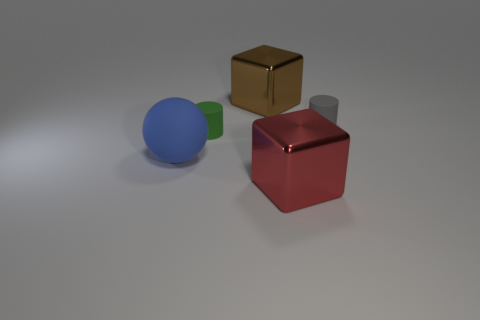How many cylinders are gray things or red metal things?
Offer a very short reply. 1. Are there the same number of tiny objects behind the brown cube and big brown blocks that are left of the green object?
Your answer should be compact. Yes. What size is the red shiny thing that is the same shape as the large brown shiny object?
Provide a short and direct response. Large. There is a thing that is both to the right of the tiny green rubber cylinder and in front of the tiny gray thing; what is its size?
Offer a very short reply. Large. Are there any things behind the large blue matte thing?
Ensure brevity in your answer.  Yes. How many objects are either small green matte things that are behind the blue rubber thing or big brown rubber blocks?
Keep it short and to the point. 1. How many tiny gray cylinders are on the right side of the big metallic object behind the gray object?
Provide a short and direct response. 1. Is the number of small rubber objects that are to the right of the red thing less than the number of matte things behind the blue matte ball?
Your response must be concise. Yes. There is a shiny object that is to the left of the shiny block that is in front of the gray object; what is its shape?
Provide a short and direct response. Cube. How many other objects are there of the same material as the green cylinder?
Give a very brief answer. 2. 